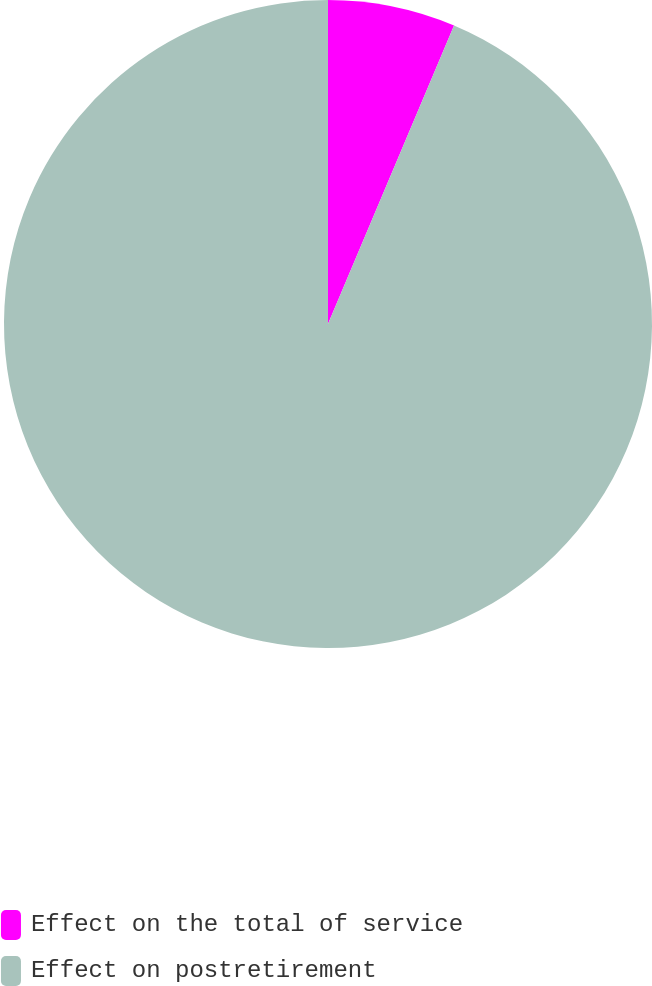Convert chart to OTSL. <chart><loc_0><loc_0><loc_500><loc_500><pie_chart><fcel>Effect on the total of service<fcel>Effect on postretirement<nl><fcel>6.36%<fcel>93.64%<nl></chart> 